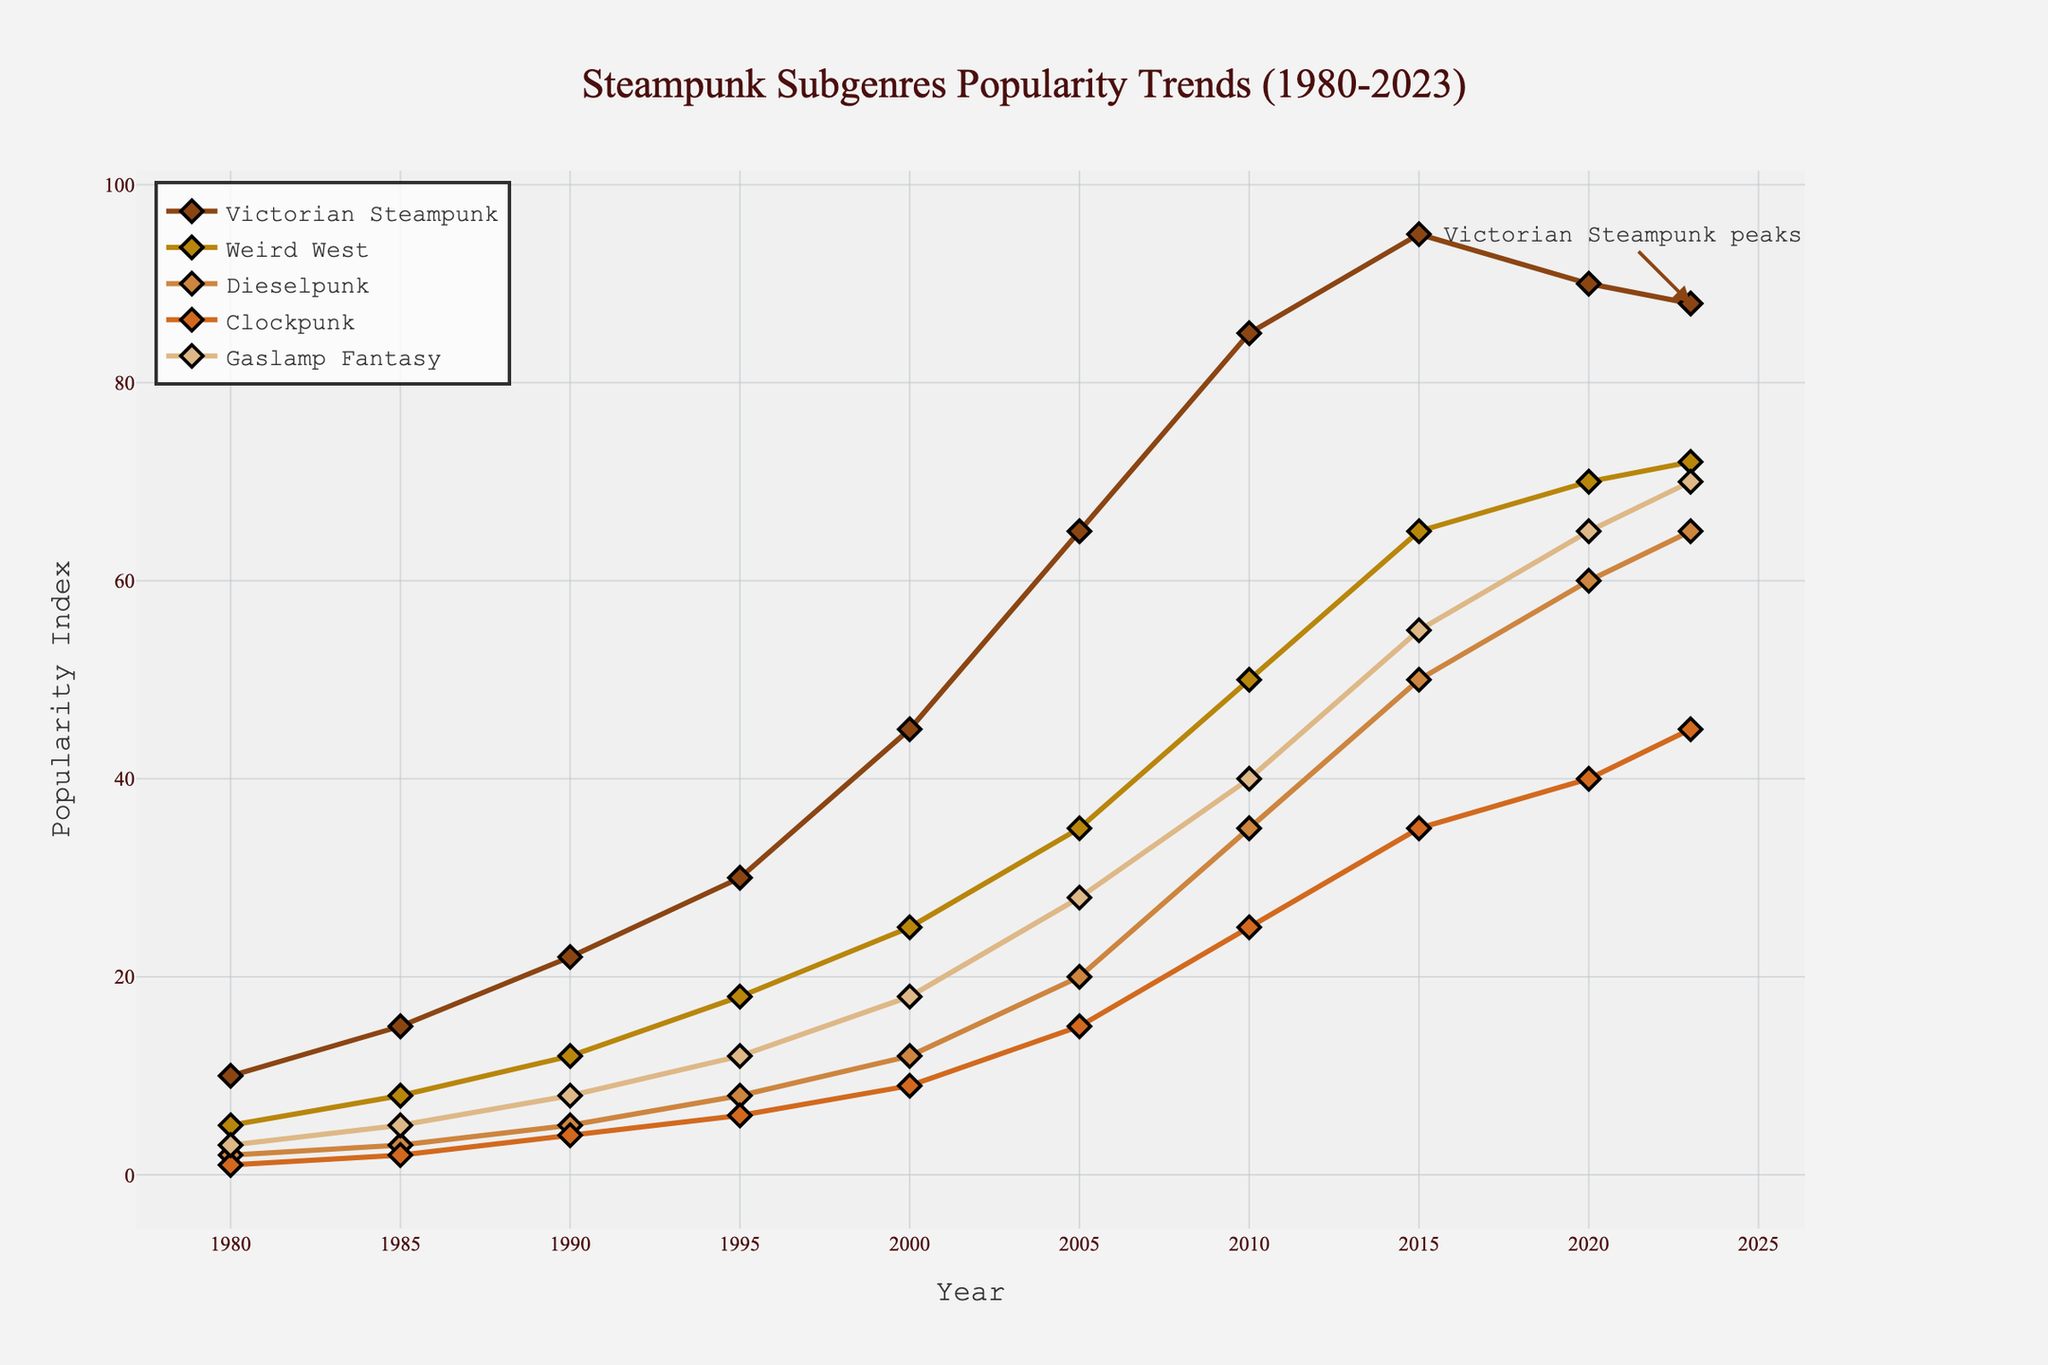What is the overall trend of Victorian Steampunk's popularity from 1980 to 2023? Victorian Steampunk shows an increasing trend in popularity from 1980, peaking around 2015, and then slightly declining but remaining high until 2023. From the graph, one can observe that the popularity index rises sharply starting from 1980 with a peak at 2015 and a slight decline afterwards.
Answer: Increasing with a peak around 2015 Which subgenre had the highest peak in popularity, and around what year was this? Gaslamp Fantasy shows the highest peak in popularity around the year 2023. This is evident from the chart where the Gaslamp Fantasy curve reaches its maximum value at this year, surpassing all other subgenres' values at any given time.
Answer: Gaslamp Fantasy, around 2023 Between 1990 and 2000, which subgenre's popularity increased the most? Dieselpunk's popularity increased the most during the period between 1990 and 2000. In 1990, its popularity index was 5, and by 2000, it increased to 12, which is a significant jump compared to the other subgenres.
Answer: Dieselpunk Compare the growth in popularity of Weird West and Clockpunk between 2005 and 2015. Which one grew more? Weird West grew from 35 in 2005 to 65 in 2015, an increase of 30. Clockpunk grew from 15 in 2005 to 35 in 2015, an increase of 20. Therefore, Weird West experienced a larger growth in popularity compared to Clockpunk during this period.
Answer: Weird West What can you infer about the popularity trends of Victorian Steampunk and Gaslamp Fantasy around 2020? Around 2020, the popularity of Victorian Steampunk started to slightly decline from its peak in 2015 whereas Gaslamp Fantasy continued to rise, showing a diverging trend between the two subgenres during this period. From the figure, the Victorian Steampunk trend dips slightly while the Gaslamp Fantasy trend continues its upward trajectory.
Answer: Victorian Steampunk slightly declined, Gaslamp Fantasy continued to rise What subgenre shows the most stable increase in popularity over the years? Gaslamp Fantasy shows the most stable increase in popularity over the years. By examining the graph, one can see a relatively smooth and consistent rise in its popularity index from 1980 to 2023 without any sudden drops.
Answer: Gaslamp Fantasy Between the years 2000 and 2010, what is the average increase in popularity for all the subgenres combined? To calculate the average increase, first find the increase for each subgenre between these years and then average them. The increases are: Victorian Steampunk (85-45)=40, Weird West (50-25)=25, Dieselpunk (35-12)=23, Clockpunk (25-9)=16, Gaslamp Fantasy (40-18)=22. Summing these gives 126, and dividing by 5 (the number of subgenres) gives an average increase of 25.2.
Answer: 25.2 How does the popularity of Dieselpunk in 1985 compare to Clockpunk in 1990? Dieselpunk had a popularity index of 3 in 1985, while Clockpunk had a popularity index of 4 in 1990. Therefore, Clockpunk was slightly more popular than Dieselpunk when comparing these specific years.
Answer: Clockpunk was more popular What visual element indicates the point of peak popularity for Victorian Steampunk? The plot includes an annotation indicating "Victorian Steampunk peaks" around the year 2023. This annotation highlights the peak point on the curve visually using an arrow to make it easily identifiable.
Answer: An annotation with an arrow on the peak point 